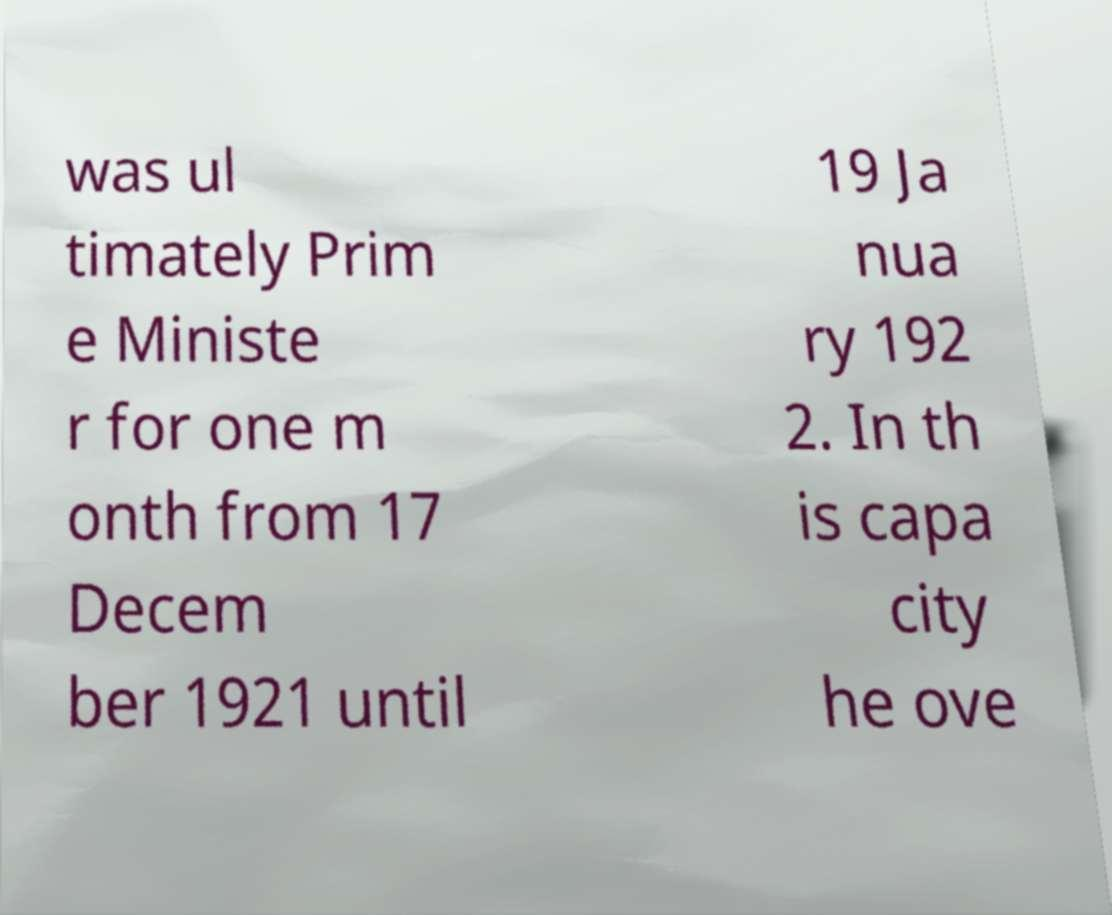Could you extract and type out the text from this image? was ul timately Prim e Ministe r for one m onth from 17 Decem ber 1921 until 19 Ja nua ry 192 2. In th is capa city he ove 